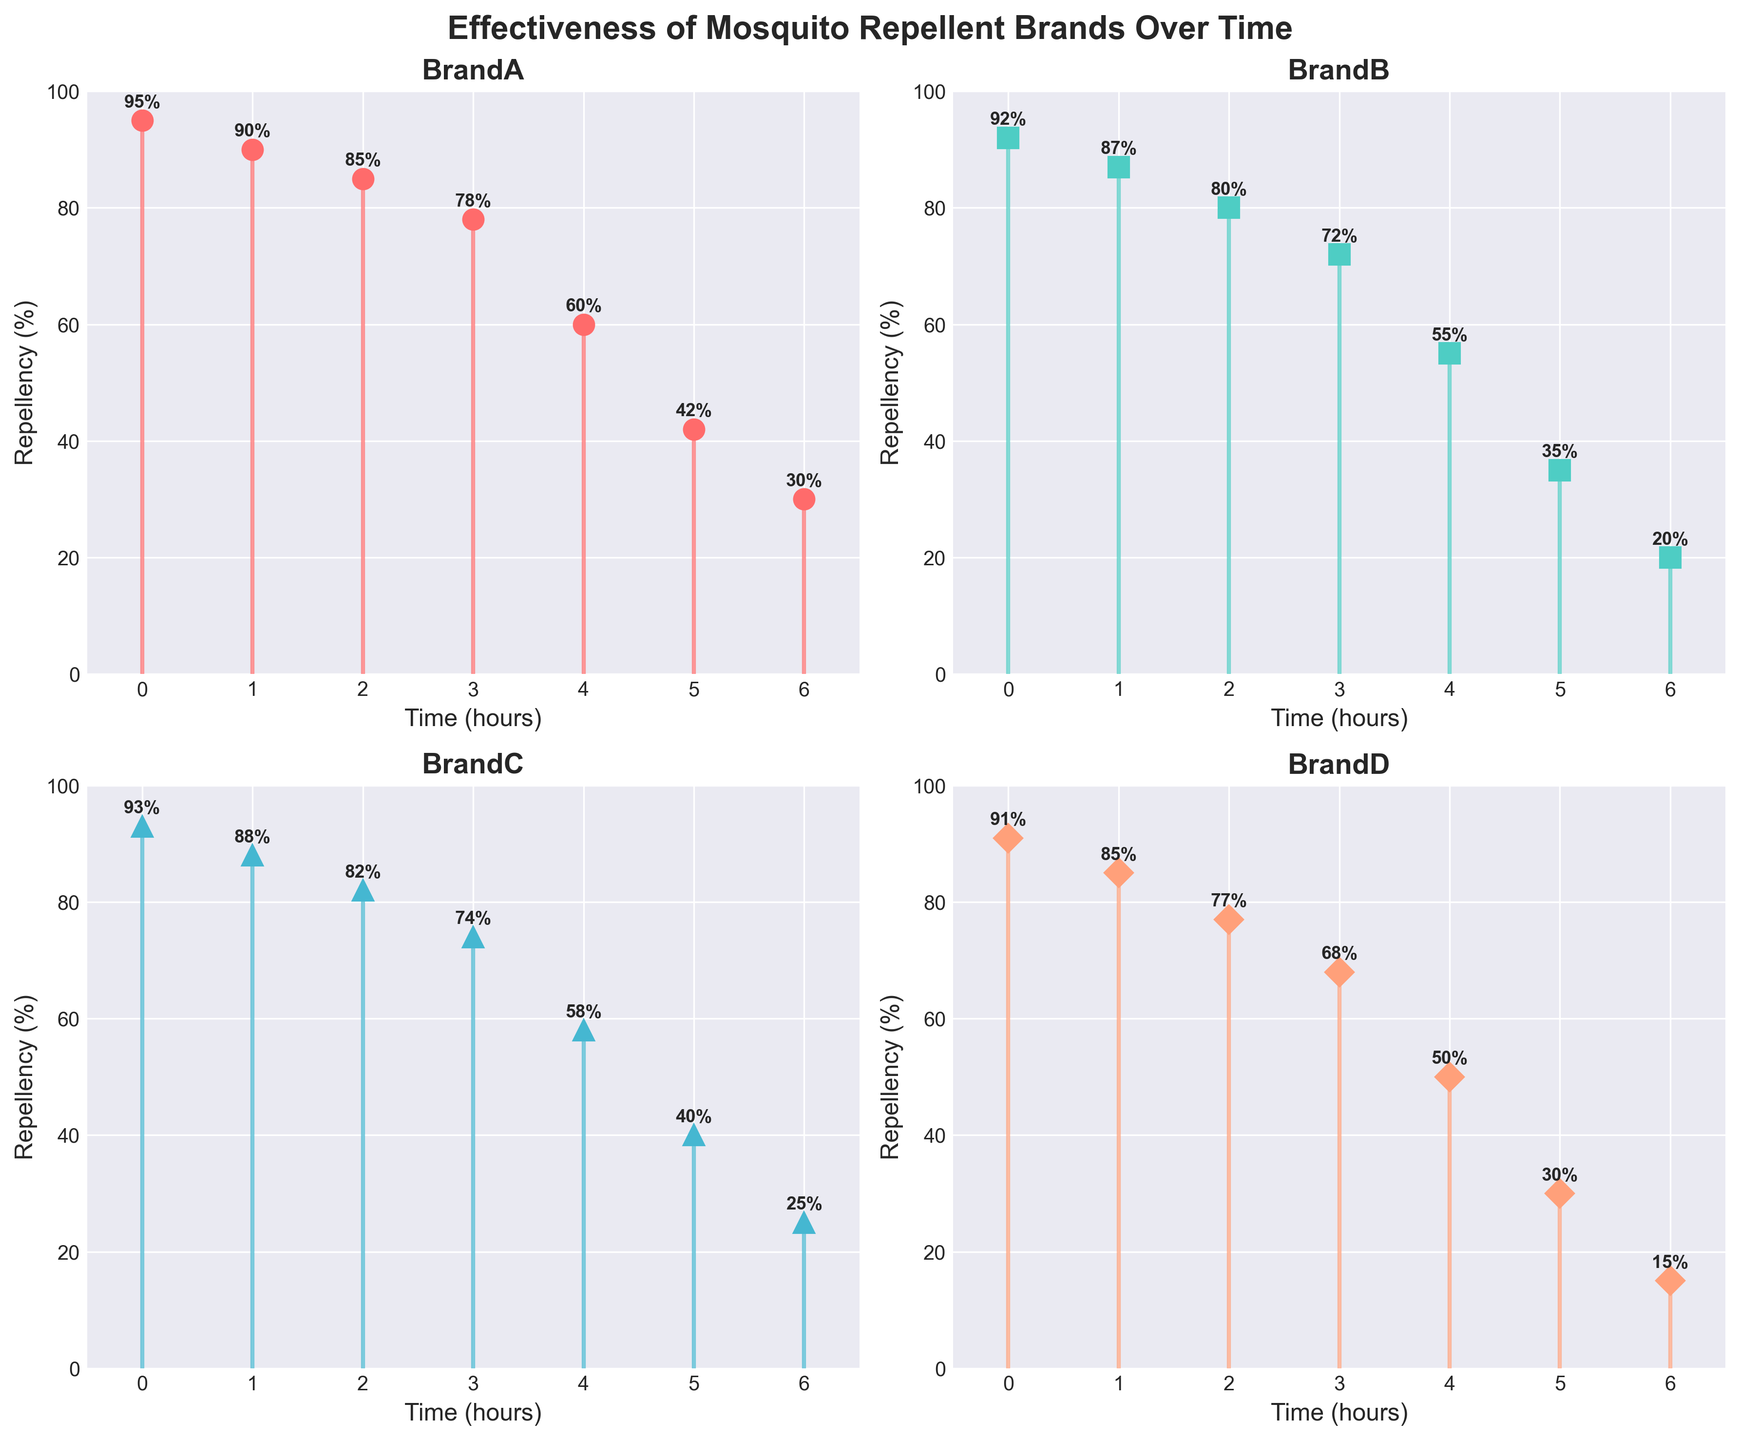what is the figure’s title? The title is located at the top of the figure and reads “Effectiveness of Mosquito Repellent Brands Over Time” in a bold and large font.
Answer: Effectiveness of Mosquito Repellent Brands Over Time How many brands are compared in the figure? The figure is divided into four subplots, each with its title representing a different mosquito repellent brand. By counting the subplots, we see that four brands are compared: BrandA, BrandB, BrandC, and BrandD.
Answer: 4 What is the repellency percentage of BrandA at time point 4? Locate the subplot for BrandA. At time point 4, the stem ends at a repellency level of 60%, which is also annotated next to the point.
Answer: 60% Which brand shows the highest repellency at time point 6? Check each subplot at time point 6 and compare the end of the stems. BrandA: 30%, BrandB: 20%, BrandC: 25%, and BrandD: 15%. The highest value is for BrandA with 30%.
Answer: BrandA How does the repellency percentage change for BrandB from time point 0 to time point 6? The plot for BrandB shows that the repellency starts at 92% at time point 0 and drops progressively to 20% by time point 6.
Answer: Decreases from 92% to 20% Which brand experienced the steepest decline between time point 3 and time point 4? By calculating the difference between time points 3 and 4 for each brand: BrandA (78%-60% = 18%), BrandB (72%-55% = 17%), BrandC (74%-58% = 16%), BrandD (68%-50% = 18%). Both BrandA and BrandD have the steepest declines of 18%.
Answer: BrandA and BrandD Compare the repellency of BrandC and BrandD at time point 2. Which is higher and by how much? At time point 2, BrandC has a repellency of 82% and BrandD has 77%. The difference is 82% - 77% = 5%.
Answer: BrandC by 5% What is the average repellency of BrandA over all time points? Add the repellency values for BrandA at all time points: 95 + 90 + 85 + 78 + 60 + 42 + 30 = 480, then divide by 7 (number of time points): 480 / 7 ≈ 68.57%.
Answer: 68.57% What can be inferred about the overall effectiveness trend of all brands over time? Observing all subplots, each brand shows a declining trend in repellency percentage over time, indicating that the effectiveness of mosquito repellents decreases as time progresses.
Answer: Decreases 